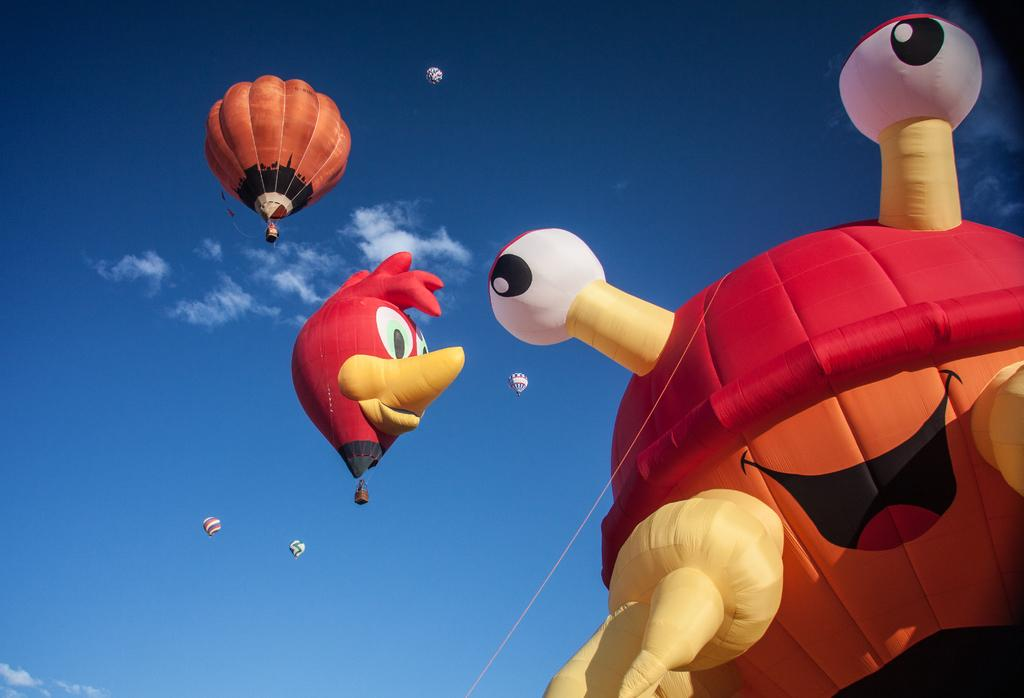What objects are featured in the picture? There are parachutes in the picture. What can be seen in the background of the picture? The sky is visible in the background of the picture. What type of disease is being treated with the parachutes in the picture? There is no disease or treatment mentioned or depicted in the image; it only features parachutes. 